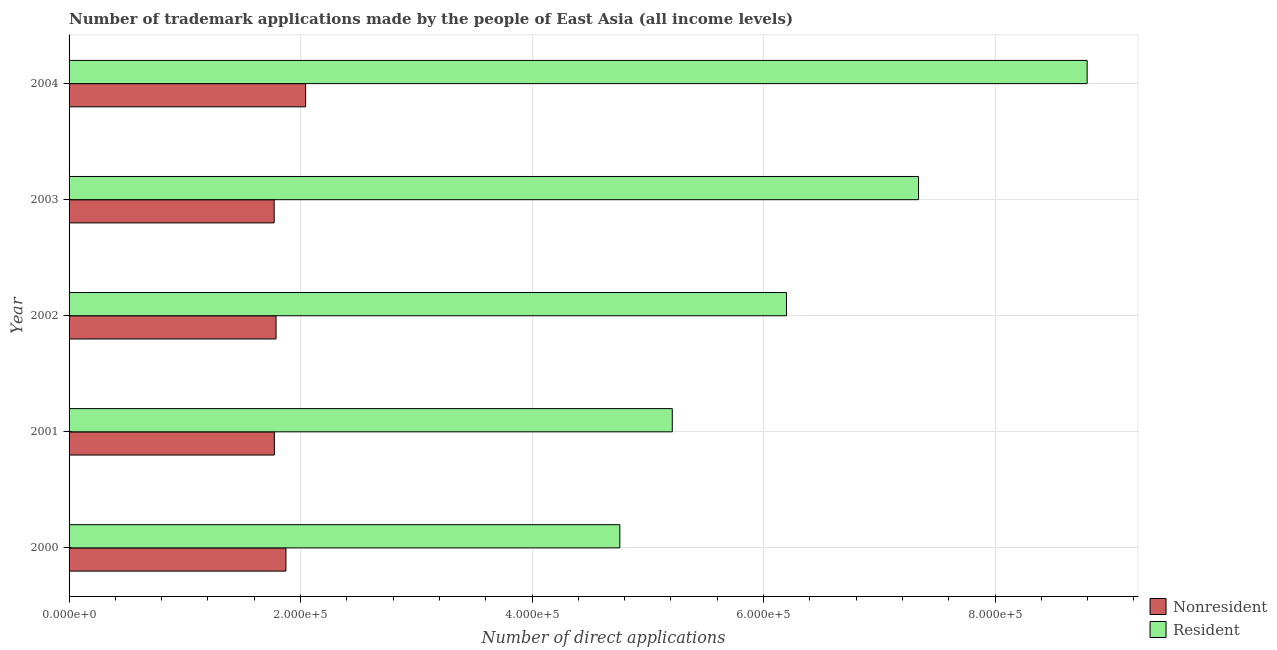Are the number of bars per tick equal to the number of legend labels?
Your response must be concise. Yes. Are the number of bars on each tick of the Y-axis equal?
Make the answer very short. Yes. How many bars are there on the 1st tick from the top?
Your answer should be compact. 2. How many bars are there on the 1st tick from the bottom?
Provide a succinct answer. 2. In how many cases, is the number of bars for a given year not equal to the number of legend labels?
Provide a short and direct response. 0. What is the number of trademark applications made by residents in 2004?
Make the answer very short. 8.80e+05. Across all years, what is the maximum number of trademark applications made by non residents?
Offer a very short reply. 2.04e+05. Across all years, what is the minimum number of trademark applications made by residents?
Provide a short and direct response. 4.76e+05. What is the total number of trademark applications made by non residents in the graph?
Your response must be concise. 9.25e+05. What is the difference between the number of trademark applications made by residents in 2001 and that in 2004?
Your response must be concise. -3.58e+05. What is the difference between the number of trademark applications made by residents in 2004 and the number of trademark applications made by non residents in 2001?
Provide a short and direct response. 7.02e+05. What is the average number of trademark applications made by non residents per year?
Provide a succinct answer. 1.85e+05. In the year 2002, what is the difference between the number of trademark applications made by residents and number of trademark applications made by non residents?
Keep it short and to the point. 4.41e+05. What is the ratio of the number of trademark applications made by non residents in 2000 to that in 2003?
Offer a very short reply. 1.06. Is the difference between the number of trademark applications made by residents in 2000 and 2003 greater than the difference between the number of trademark applications made by non residents in 2000 and 2003?
Provide a short and direct response. No. What is the difference between the highest and the second highest number of trademark applications made by non residents?
Ensure brevity in your answer.  1.70e+04. What is the difference between the highest and the lowest number of trademark applications made by residents?
Your answer should be very brief. 4.04e+05. Is the sum of the number of trademark applications made by residents in 2000 and 2002 greater than the maximum number of trademark applications made by non residents across all years?
Offer a very short reply. Yes. What does the 1st bar from the top in 2003 represents?
Ensure brevity in your answer.  Resident. What does the 2nd bar from the bottom in 2001 represents?
Provide a succinct answer. Resident. How many years are there in the graph?
Your answer should be compact. 5. Are the values on the major ticks of X-axis written in scientific E-notation?
Offer a very short reply. Yes. What is the title of the graph?
Your answer should be very brief. Number of trademark applications made by the people of East Asia (all income levels). What is the label or title of the X-axis?
Keep it short and to the point. Number of direct applications. What is the Number of direct applications in Nonresident in 2000?
Your answer should be compact. 1.87e+05. What is the Number of direct applications of Resident in 2000?
Provide a short and direct response. 4.76e+05. What is the Number of direct applications in Nonresident in 2001?
Ensure brevity in your answer.  1.77e+05. What is the Number of direct applications of Resident in 2001?
Provide a succinct answer. 5.21e+05. What is the Number of direct applications in Nonresident in 2002?
Your answer should be very brief. 1.79e+05. What is the Number of direct applications in Resident in 2002?
Your response must be concise. 6.20e+05. What is the Number of direct applications of Nonresident in 2003?
Offer a terse response. 1.77e+05. What is the Number of direct applications of Resident in 2003?
Your answer should be very brief. 7.34e+05. What is the Number of direct applications in Nonresident in 2004?
Your response must be concise. 2.04e+05. What is the Number of direct applications of Resident in 2004?
Give a very brief answer. 8.80e+05. Across all years, what is the maximum Number of direct applications in Nonresident?
Offer a terse response. 2.04e+05. Across all years, what is the maximum Number of direct applications of Resident?
Provide a succinct answer. 8.80e+05. Across all years, what is the minimum Number of direct applications in Nonresident?
Offer a terse response. 1.77e+05. Across all years, what is the minimum Number of direct applications in Resident?
Offer a very short reply. 4.76e+05. What is the total Number of direct applications of Nonresident in the graph?
Your answer should be compact. 9.25e+05. What is the total Number of direct applications in Resident in the graph?
Provide a succinct answer. 3.23e+06. What is the difference between the Number of direct applications in Nonresident in 2000 and that in 2001?
Give a very brief answer. 9993. What is the difference between the Number of direct applications of Resident in 2000 and that in 2001?
Ensure brevity in your answer.  -4.53e+04. What is the difference between the Number of direct applications of Nonresident in 2000 and that in 2002?
Your answer should be compact. 8533. What is the difference between the Number of direct applications in Resident in 2000 and that in 2002?
Offer a very short reply. -1.44e+05. What is the difference between the Number of direct applications in Nonresident in 2000 and that in 2003?
Provide a succinct answer. 1.02e+04. What is the difference between the Number of direct applications of Resident in 2000 and that in 2003?
Provide a short and direct response. -2.58e+05. What is the difference between the Number of direct applications in Nonresident in 2000 and that in 2004?
Give a very brief answer. -1.70e+04. What is the difference between the Number of direct applications of Resident in 2000 and that in 2004?
Your answer should be very brief. -4.04e+05. What is the difference between the Number of direct applications in Nonresident in 2001 and that in 2002?
Offer a terse response. -1460. What is the difference between the Number of direct applications in Resident in 2001 and that in 2002?
Offer a very short reply. -9.87e+04. What is the difference between the Number of direct applications in Nonresident in 2001 and that in 2003?
Ensure brevity in your answer.  176. What is the difference between the Number of direct applications of Resident in 2001 and that in 2003?
Make the answer very short. -2.13e+05. What is the difference between the Number of direct applications of Nonresident in 2001 and that in 2004?
Keep it short and to the point. -2.70e+04. What is the difference between the Number of direct applications of Resident in 2001 and that in 2004?
Make the answer very short. -3.58e+05. What is the difference between the Number of direct applications of Nonresident in 2002 and that in 2003?
Make the answer very short. 1636. What is the difference between the Number of direct applications in Resident in 2002 and that in 2003?
Provide a succinct answer. -1.14e+05. What is the difference between the Number of direct applications of Nonresident in 2002 and that in 2004?
Provide a succinct answer. -2.55e+04. What is the difference between the Number of direct applications in Resident in 2002 and that in 2004?
Your answer should be compact. -2.60e+05. What is the difference between the Number of direct applications in Nonresident in 2003 and that in 2004?
Your answer should be compact. -2.72e+04. What is the difference between the Number of direct applications of Resident in 2003 and that in 2004?
Ensure brevity in your answer.  -1.46e+05. What is the difference between the Number of direct applications in Nonresident in 2000 and the Number of direct applications in Resident in 2001?
Offer a very short reply. -3.34e+05. What is the difference between the Number of direct applications in Nonresident in 2000 and the Number of direct applications in Resident in 2002?
Provide a succinct answer. -4.32e+05. What is the difference between the Number of direct applications in Nonresident in 2000 and the Number of direct applications in Resident in 2003?
Keep it short and to the point. -5.47e+05. What is the difference between the Number of direct applications in Nonresident in 2000 and the Number of direct applications in Resident in 2004?
Your response must be concise. -6.92e+05. What is the difference between the Number of direct applications in Nonresident in 2001 and the Number of direct applications in Resident in 2002?
Your answer should be compact. -4.42e+05. What is the difference between the Number of direct applications in Nonresident in 2001 and the Number of direct applications in Resident in 2003?
Give a very brief answer. -5.57e+05. What is the difference between the Number of direct applications in Nonresident in 2001 and the Number of direct applications in Resident in 2004?
Your answer should be very brief. -7.02e+05. What is the difference between the Number of direct applications of Nonresident in 2002 and the Number of direct applications of Resident in 2003?
Offer a very short reply. -5.55e+05. What is the difference between the Number of direct applications of Nonresident in 2002 and the Number of direct applications of Resident in 2004?
Provide a short and direct response. -7.01e+05. What is the difference between the Number of direct applications in Nonresident in 2003 and the Number of direct applications in Resident in 2004?
Your response must be concise. -7.02e+05. What is the average Number of direct applications in Nonresident per year?
Ensure brevity in your answer.  1.85e+05. What is the average Number of direct applications of Resident per year?
Your answer should be compact. 6.46e+05. In the year 2000, what is the difference between the Number of direct applications of Nonresident and Number of direct applications of Resident?
Offer a very short reply. -2.88e+05. In the year 2001, what is the difference between the Number of direct applications of Nonresident and Number of direct applications of Resident?
Your answer should be very brief. -3.44e+05. In the year 2002, what is the difference between the Number of direct applications of Nonresident and Number of direct applications of Resident?
Your response must be concise. -4.41e+05. In the year 2003, what is the difference between the Number of direct applications of Nonresident and Number of direct applications of Resident?
Offer a terse response. -5.57e+05. In the year 2004, what is the difference between the Number of direct applications of Nonresident and Number of direct applications of Resident?
Provide a succinct answer. -6.75e+05. What is the ratio of the Number of direct applications of Nonresident in 2000 to that in 2001?
Give a very brief answer. 1.06. What is the ratio of the Number of direct applications in Resident in 2000 to that in 2001?
Provide a succinct answer. 0.91. What is the ratio of the Number of direct applications of Nonresident in 2000 to that in 2002?
Keep it short and to the point. 1.05. What is the ratio of the Number of direct applications in Resident in 2000 to that in 2002?
Offer a very short reply. 0.77. What is the ratio of the Number of direct applications in Nonresident in 2000 to that in 2003?
Keep it short and to the point. 1.06. What is the ratio of the Number of direct applications in Resident in 2000 to that in 2003?
Your answer should be compact. 0.65. What is the ratio of the Number of direct applications in Nonresident in 2000 to that in 2004?
Provide a short and direct response. 0.92. What is the ratio of the Number of direct applications in Resident in 2000 to that in 2004?
Make the answer very short. 0.54. What is the ratio of the Number of direct applications of Nonresident in 2001 to that in 2002?
Your response must be concise. 0.99. What is the ratio of the Number of direct applications in Resident in 2001 to that in 2002?
Give a very brief answer. 0.84. What is the ratio of the Number of direct applications in Resident in 2001 to that in 2003?
Ensure brevity in your answer.  0.71. What is the ratio of the Number of direct applications in Nonresident in 2001 to that in 2004?
Provide a succinct answer. 0.87. What is the ratio of the Number of direct applications of Resident in 2001 to that in 2004?
Your answer should be very brief. 0.59. What is the ratio of the Number of direct applications of Nonresident in 2002 to that in 2003?
Provide a short and direct response. 1.01. What is the ratio of the Number of direct applications in Resident in 2002 to that in 2003?
Make the answer very short. 0.84. What is the ratio of the Number of direct applications of Resident in 2002 to that in 2004?
Offer a very short reply. 0.7. What is the ratio of the Number of direct applications of Nonresident in 2003 to that in 2004?
Ensure brevity in your answer.  0.87. What is the ratio of the Number of direct applications of Resident in 2003 to that in 2004?
Ensure brevity in your answer.  0.83. What is the difference between the highest and the second highest Number of direct applications of Nonresident?
Ensure brevity in your answer.  1.70e+04. What is the difference between the highest and the second highest Number of direct applications of Resident?
Ensure brevity in your answer.  1.46e+05. What is the difference between the highest and the lowest Number of direct applications of Nonresident?
Your answer should be compact. 2.72e+04. What is the difference between the highest and the lowest Number of direct applications of Resident?
Your answer should be very brief. 4.04e+05. 